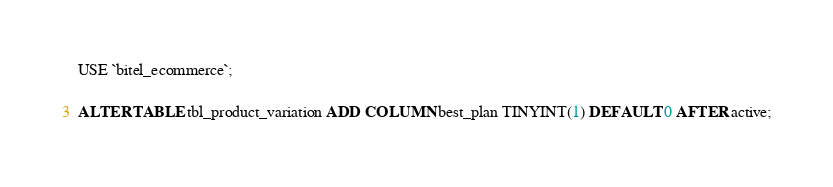Convert code to text. <code><loc_0><loc_0><loc_500><loc_500><_SQL_>USE `bitel_ecommerce`;

ALTER TABLE tbl_product_variation ADD COLUMN best_plan TINYINT(1) DEFAULT 0 AFTER active;
</code> 